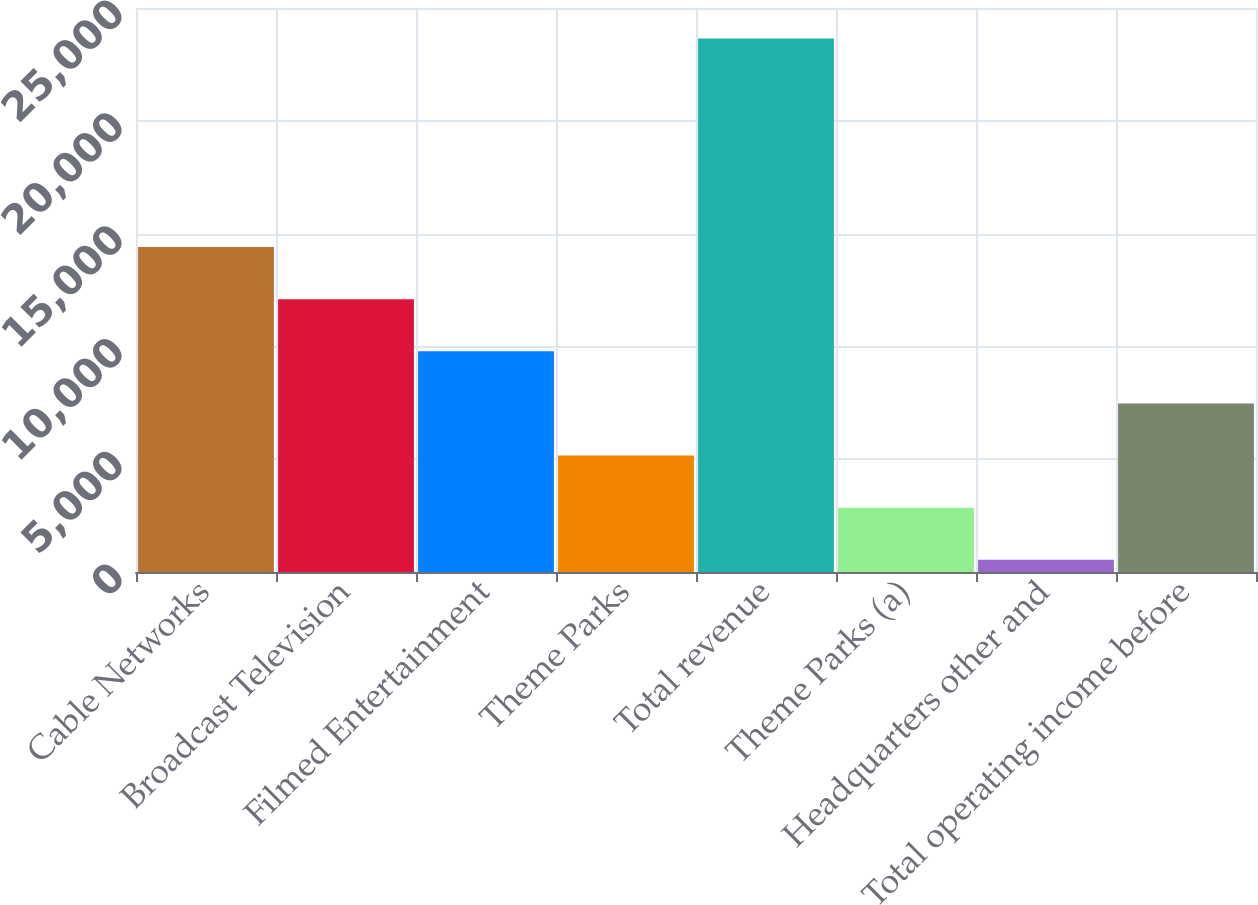Convert chart to OTSL. <chart><loc_0><loc_0><loc_500><loc_500><bar_chart><fcel>Cable Networks<fcel>Broadcast Television<fcel>Filmed Entertainment<fcel>Theme Parks<fcel>Total revenue<fcel>Theme Parks (a)<fcel>Headquarters other and<fcel>Total operating income before<nl><fcel>14406<fcel>12095<fcel>9784<fcel>5162<fcel>23650<fcel>2851<fcel>540<fcel>7473<nl></chart> 